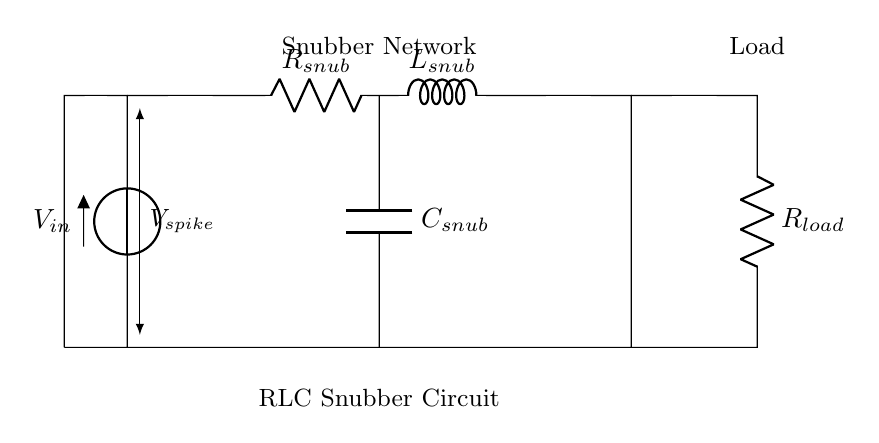What is the function of the capacitor in the snubber circuit? The capacitor in the snubber circuit serves to absorb and store energy from voltage spikes, helping to smooth out transients and protect the load from excessive voltage.
Answer: Absorb voltage spikes What are the components of the snubber network? The snubber network consists of a resistor, inductor, and capacitor, designed to work together to suppress voltage spikes and protect the load.
Answer: Resistor, inductor, capacitor What is the role of the resistor in the RLC snubber circuit? The resistor is used to limit current and dampen oscillations in the snubber circuit, contributing to the overall damping effect to stabilize voltage levels.
Answer: Limit current and dampen oscillations How many components are connected in series in the snubber network? There are three components connected in series within the snubber network: the resistor, inductor, and capacitor.
Answer: Three What is the main purpose of an RLC snubber circuit? The main purpose of an RLC snubber circuit is to suppress voltage spikes and transients that occur in power supply systems to protect sensitive electronics.
Answer: Suppress voltage spikes What type of load is shown in the circuit diagram? The circuit diagram shows a resistive load connected in parallel with the snubber network, which likely draws power from the power supply.
Answer: Resistive load What is the significance of \( V_{spike} \) in the circuit? \( V_{spike} \) represents the voltage level of the transient that the snubber circuit is designed to suppress, indicating the need for voltage protection.
Answer: Voltage spike 